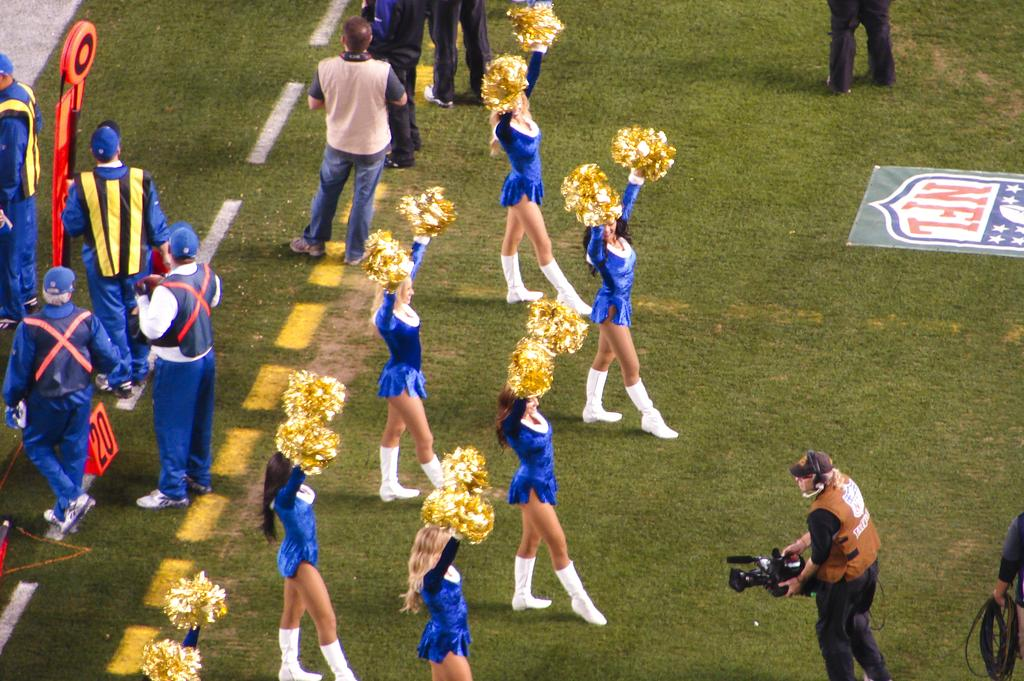<image>
Render a clear and concise summary of the photo. Cheerleaders stand by an NFL logo while being filmed. 